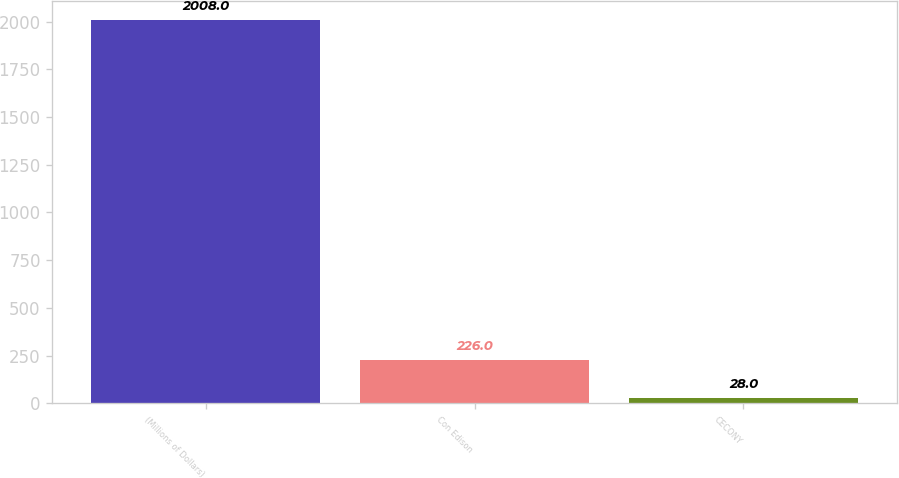Convert chart to OTSL. <chart><loc_0><loc_0><loc_500><loc_500><bar_chart><fcel>(Millions of Dollars)<fcel>Con Edison<fcel>CECONY<nl><fcel>2008<fcel>226<fcel>28<nl></chart> 